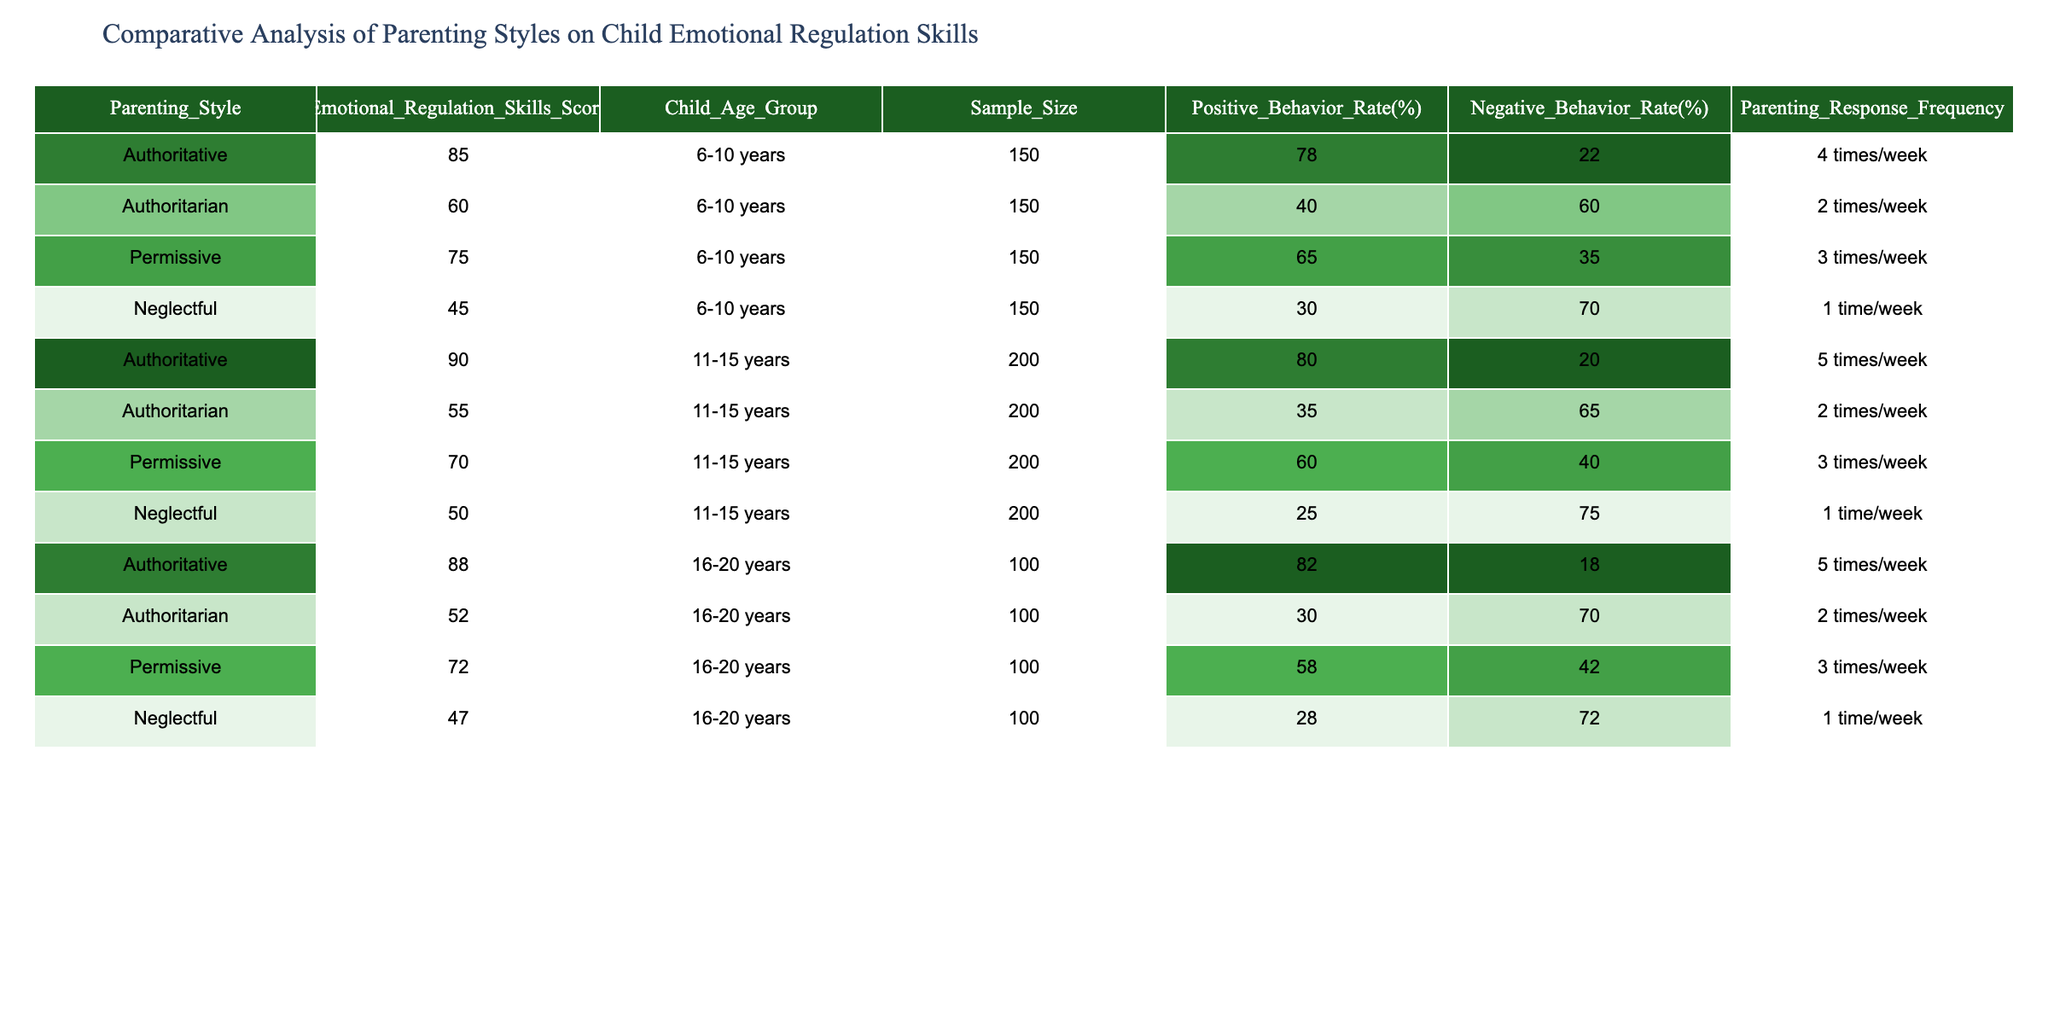What is the Emotional Regulation Skills Score for authoritative parenting in the 11-15 years age group? The table shows the score for authoritative parenting under the age group of 11-15 years, which is listed as 90.
Answer: 90 Which parenting style has the highest Negative Behavior Rate in 6-10 years age group? The table indicates that the Neglectful parenting style has a Negative Behavior Rate of 70%, which is the highest among all styles in that age group.
Answer: Neglectful What is the average Emotional Regulation Skills Score for permissive parenting across all age groups? From the table, the Emotional Regulation Skills Scores for permissive parenting are 75, 70, and 72 for the age groups 6-10, 11-15, and 16-20 respectively. Summing these gives (75 + 70 + 72) = 217, and dividing by 3 (the number of age groups) gives an average of 217/3 = 72.33.
Answer: 72.33 Is the Positive Behavior Rate higher for authoritative parents compared to authoritarian parents in the 16-20 years age group? The Positive Behavior Rate for authoritative parents in the 16-20 age group is 82%, while for authoritarian parents it is 30%. Since 82% is greater than 30%, the statement is true.
Answer: Yes Which parenting style shows the most improvement in Emotional Regulation Skills Score from the 11-15 years age group to the 16-20 years age group? From the table, authoritative parenting scores 90 in the 11-15 age group and 88 in the 16-20 age group (a decrease of 2). Authoritarian parenting scores 55 and 52 respectively (a decrease of 3). Permissive parenting scores 70 and 72 respectively (an increase of 2). Neglectful parenting scores 50 and 47 respectively (a decrease of 3). Permissive shows the most improvement.
Answer: Permissive What is the relationship between Parenting Response Frequency and Emotional Regulation Skills Score within the authoritative parenting style across all age groups? For authoritative parenting, the scores are 85 (4 times/week), 90 (5 times/week), and 88 (5 times/week). The Emotional Regulation Skills Score does not decrease with an increase in response frequency clearly. Thus, higher frequency does not correspond to an increase in score consistently.
Answer: No clear relationship What is the total sample size for the authoritarian parenting style across all age groups? The table indicates a sample size of 150 for the 6-10 years age group, 200 for the 11-15 years, and 100 for the 16-20 years age group. Summing these gives (150 + 200 + 100) = 450.
Answer: 450 Did any parenting style achieve a Positive Behavior Rate over 80%? Reviewing the Positive Behavior Rate in the table, only the authoritative parenting style in the age groups 11-15 and 16-20 achieved rates of 80% and 82% respectively, confirming the occurrence.
Answer: Yes How does the Emotional Regulation Skills Score for neglectful parenting compare to that of permissive parenting in the 11-15 years age group? The Emotional Regulation Skills Score for permissive parenting in that age group is 70, while for neglectful parenting it is 50. Since 70 is higher than 50, it shows that permissive parenting is more favorable in terms of Emotional Regulation Skills.
Answer: Permissive parenting is higher 